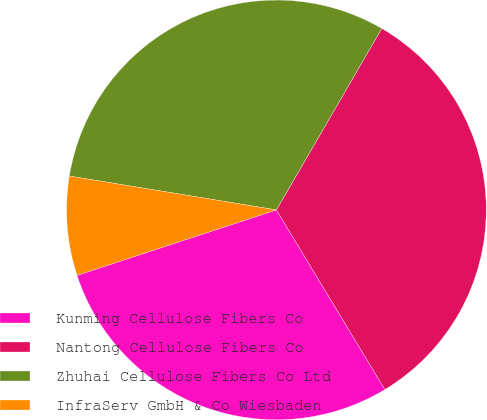Convert chart to OTSL. <chart><loc_0><loc_0><loc_500><loc_500><pie_chart><fcel>Kunming Cellulose Fibers Co<fcel>Nantong Cellulose Fibers Co<fcel>Zhuhai Cellulose Fibers Co Ltd<fcel>InfraServ GmbH & Co Wiesbaden<nl><fcel>28.6%<fcel>32.98%<fcel>30.79%<fcel>7.63%<nl></chart> 